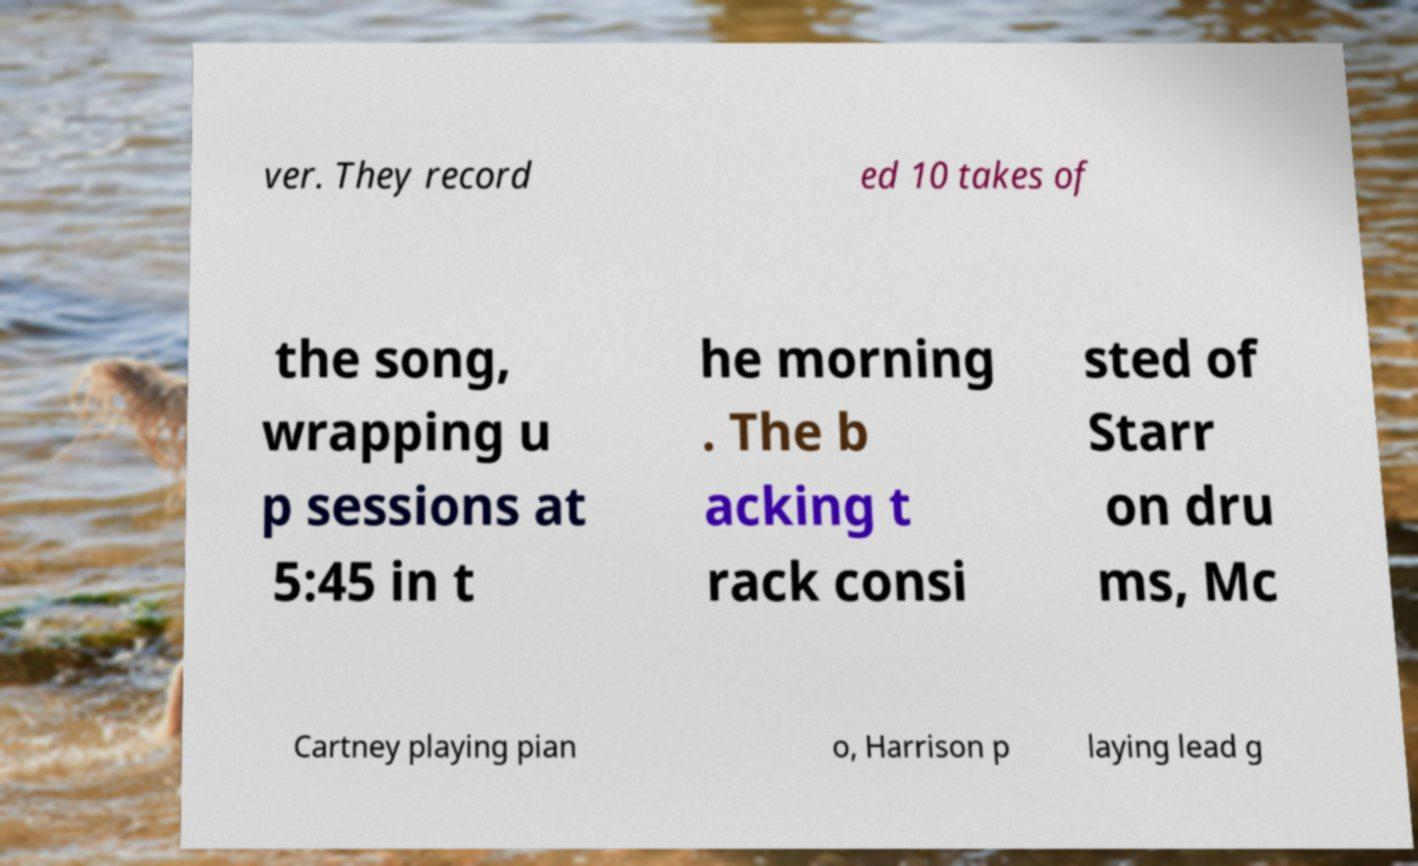Can you accurately transcribe the text from the provided image for me? ver. They record ed 10 takes of the song, wrapping u p sessions at 5:45 in t he morning . The b acking t rack consi sted of Starr on dru ms, Mc Cartney playing pian o, Harrison p laying lead g 